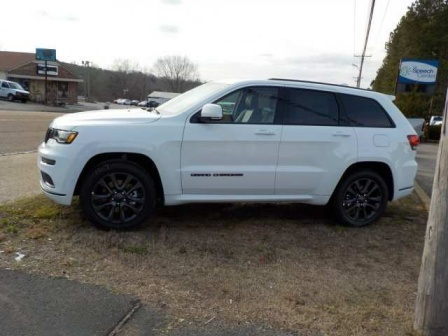Can you describe the main features of this image for me? The image captures a white Jeep Grand Cherokee parked on a grassy patch near a road. The vehicle is oriented to the right, highlighting its sleek design, black rims, and elegant black grille. The background features a roadside area with a blue sign and a building with a brown roof, which hints at a suburban or rural setting. The surroundings, including the utility pole and distant trees without leaves, suggest a quiet, possibly off-season day. 